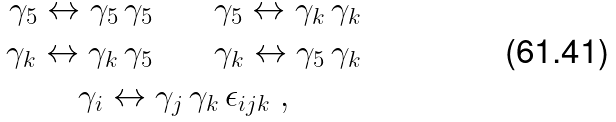Convert formula to latex. <formula><loc_0><loc_0><loc_500><loc_500>\gamma _ { 5 } \leftrightarrow \gamma _ { 5 } \, \gamma _ { 5 } \quad & \quad \gamma _ { 5 } \leftrightarrow \gamma _ { k } \, \gamma _ { k } \\ \gamma _ { k } \leftrightarrow \gamma _ { k } \, \gamma _ { 5 } \quad & \quad \gamma _ { k } \leftrightarrow \gamma _ { 5 } \, \gamma _ { k } \\ \gamma _ { i } \leftrightarrow \gamma _ { j } & \, \gamma _ { k } \, \epsilon _ { i j k } \ ,</formula> 